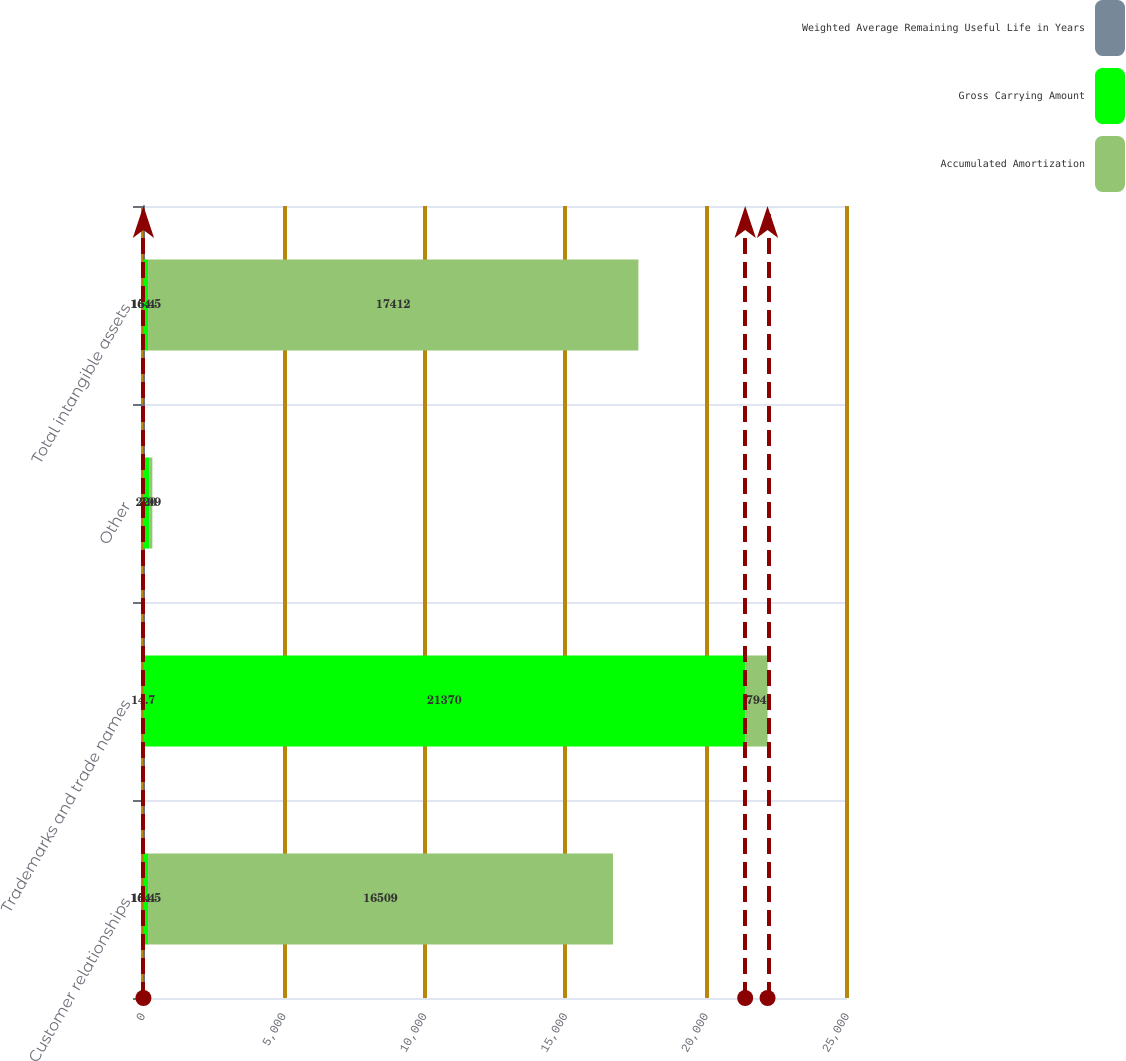Convert chart. <chart><loc_0><loc_0><loc_500><loc_500><stacked_bar_chart><ecel><fcel>Customer relationships<fcel>Trademarks and trade names<fcel>Other<fcel>Total intangible assets<nl><fcel>Weighted Average Remaining Useful Life in Years<fcel>15.4<fcel>14.7<fcel>3<fcel>15.4<nl><fcel>Gross Carrying Amount<fcel>164.5<fcel>21370<fcel>220<fcel>164.5<nl><fcel>Accumulated Amortization<fcel>16509<fcel>794<fcel>109<fcel>17412<nl></chart> 